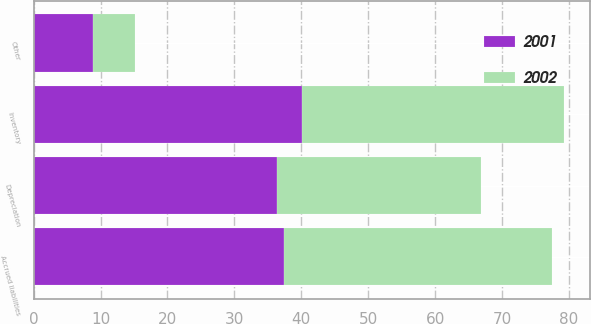<chart> <loc_0><loc_0><loc_500><loc_500><stacked_bar_chart><ecel><fcel>Inventory<fcel>Depreciation<fcel>Accrued liabilities<fcel>Other<nl><fcel>2001<fcel>40.1<fcel>36.3<fcel>37.4<fcel>8.9<nl><fcel>2002<fcel>39.1<fcel>30.6<fcel>40.1<fcel>6.2<nl></chart> 